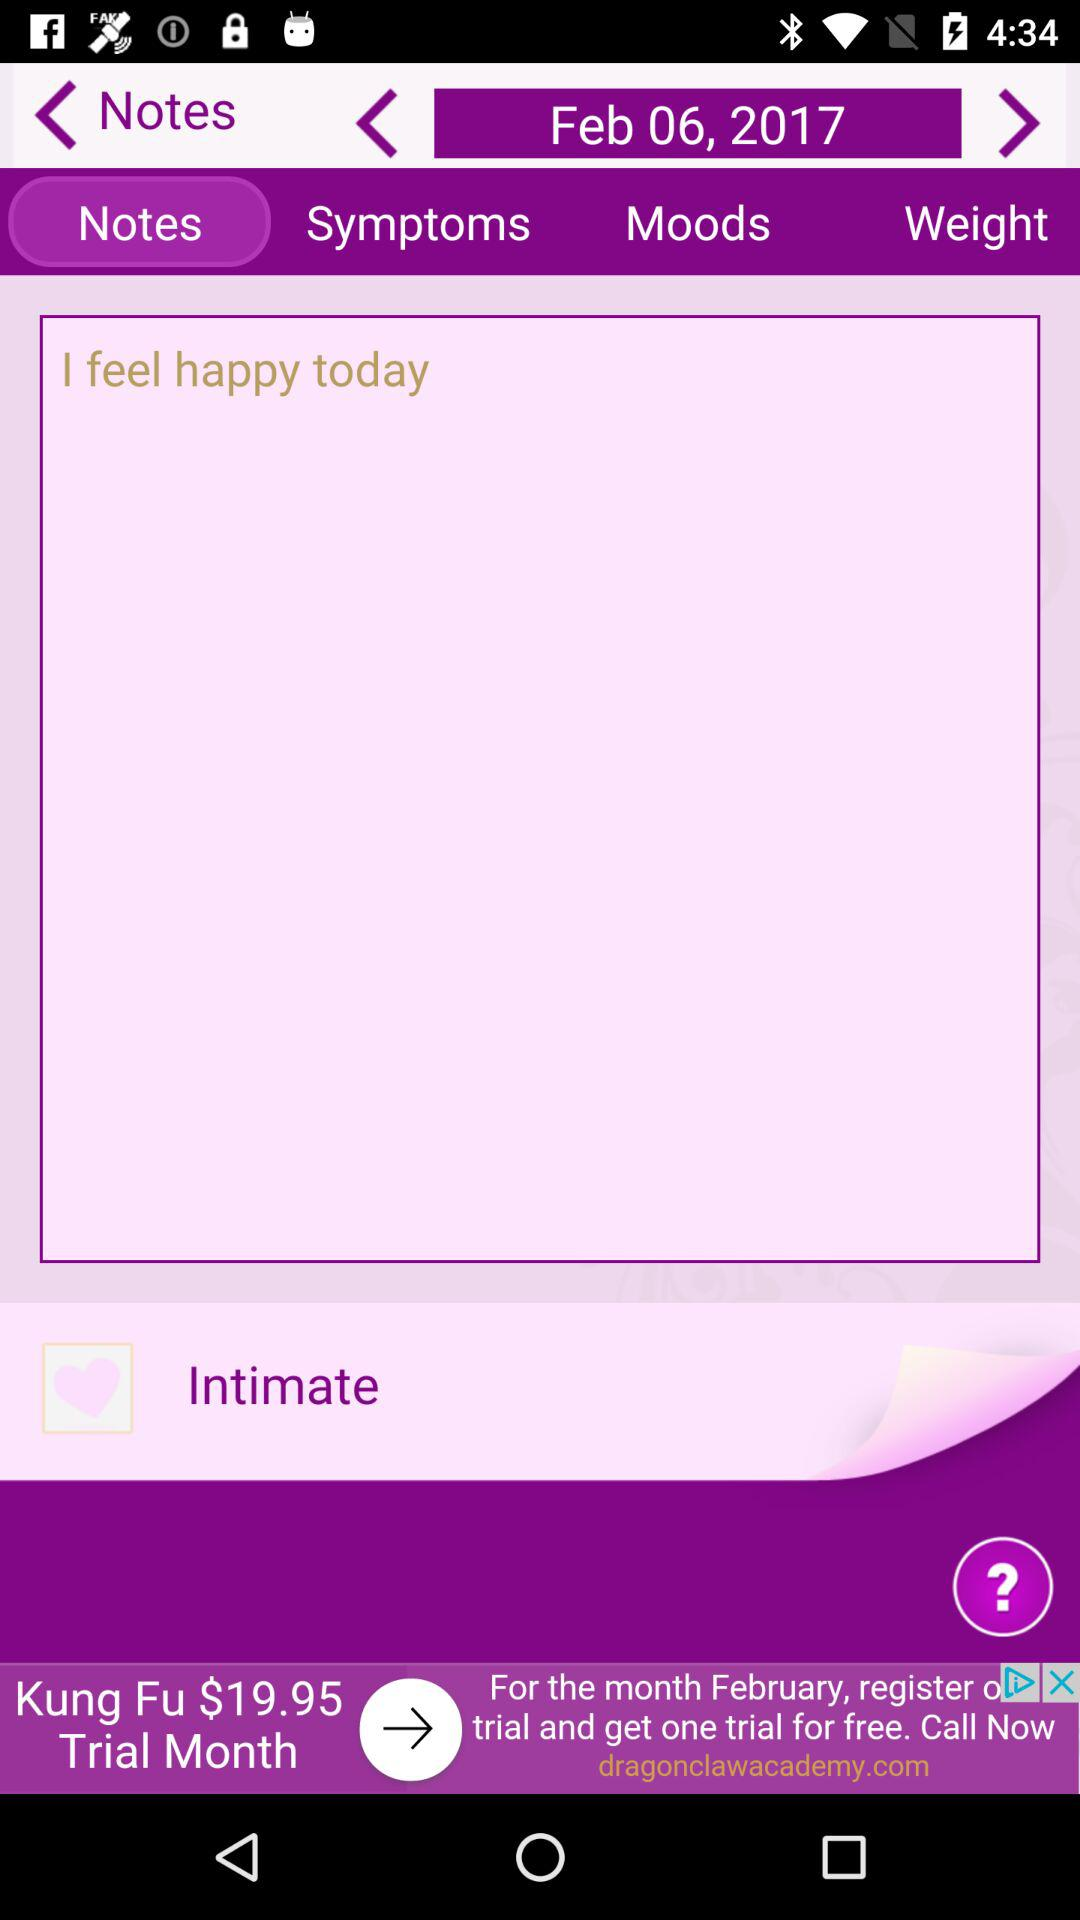Which option is selected? The selected option is "Notes". 